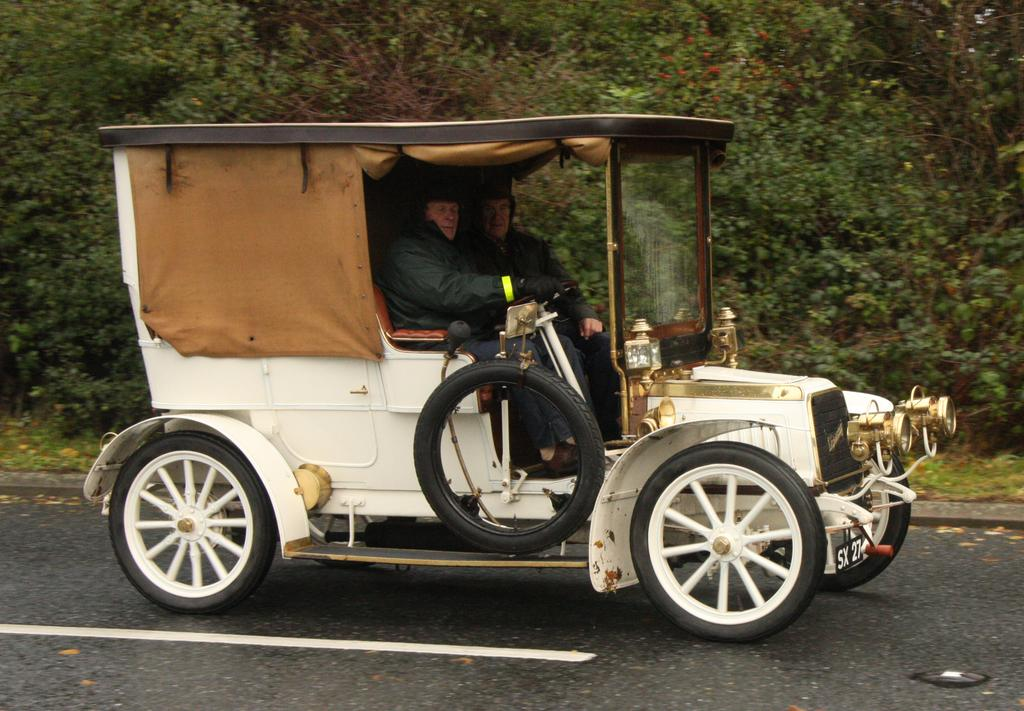What type of vehicle is in the picture? There is a vintage car in the picture. Who is inside the car? Two people are sitting in the car. What is the surface behind the car? There is a grass surface behind the car. What can be seen growing on the grass surface? There are many plants on the grass surface. What type of apparel are the girls wearing in the picture? There are no girls present in the image; it features a vintage car with two people inside. 